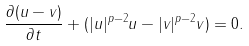<formula> <loc_0><loc_0><loc_500><loc_500>\frac { \partial ( u - v ) } { \partial t } + ( | u | ^ { p - 2 } u - | v | ^ { p - 2 } v ) = 0 .</formula> 